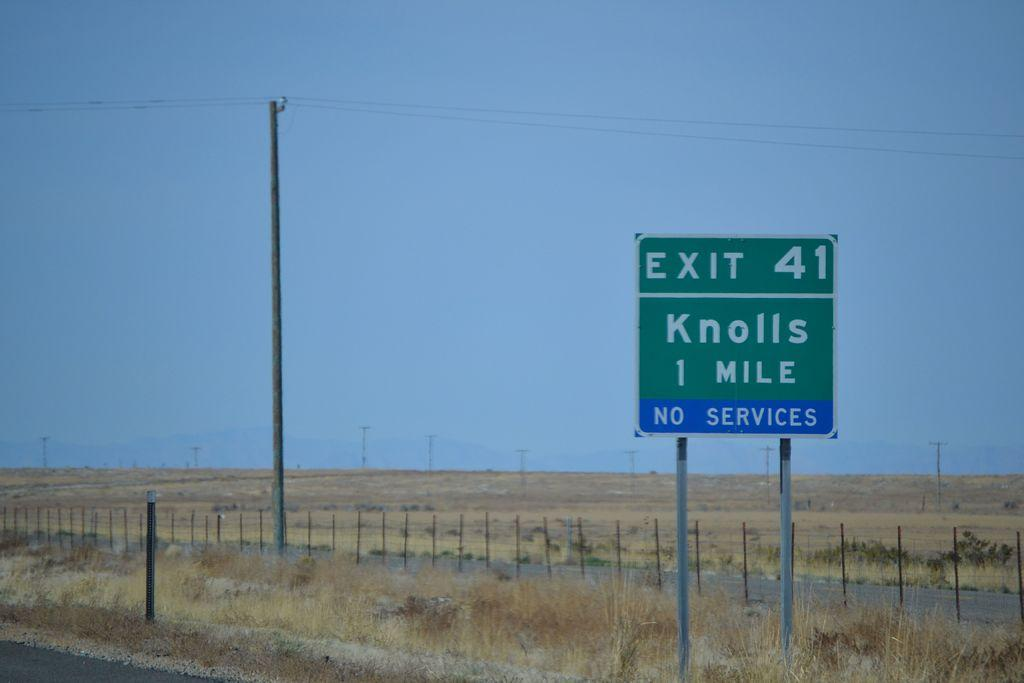Provide a one-sentence caption for the provided image. a knolls sign with exit 41 on it. 